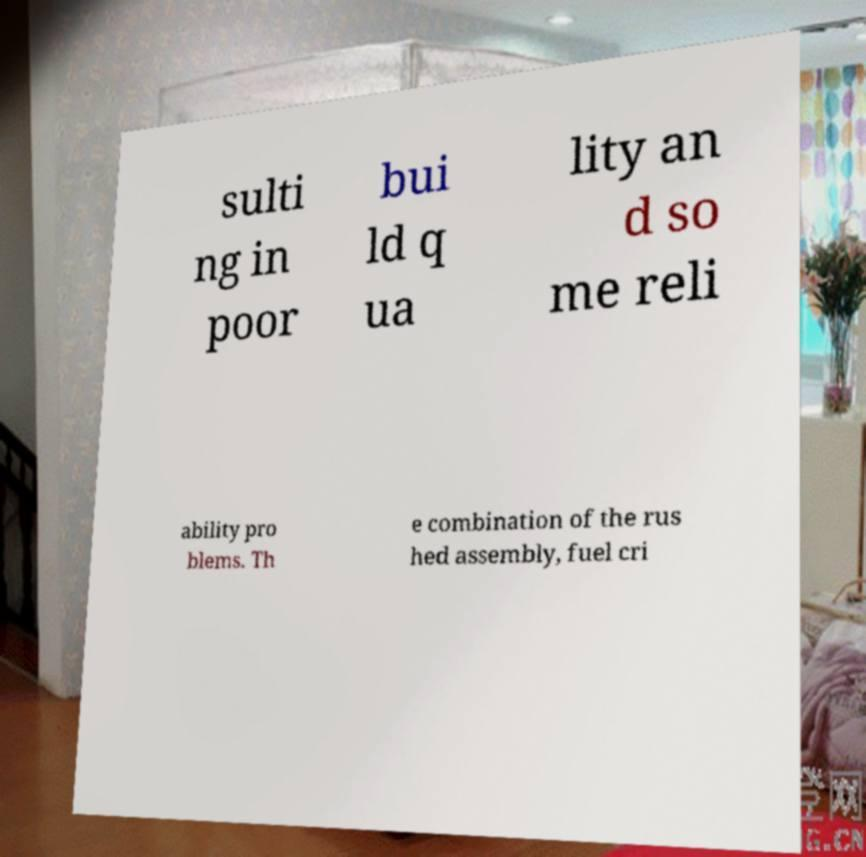There's text embedded in this image that I need extracted. Can you transcribe it verbatim? sulti ng in poor bui ld q ua lity an d so me reli ability pro blems. Th e combination of the rus hed assembly, fuel cri 